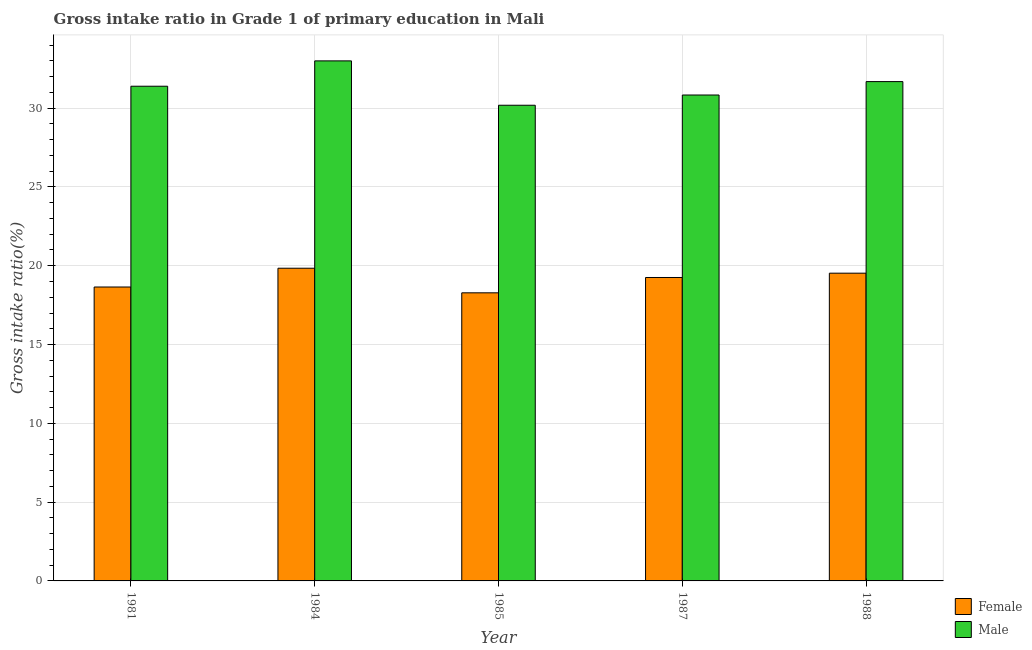How many different coloured bars are there?
Make the answer very short. 2. How many groups of bars are there?
Provide a succinct answer. 5. What is the gross intake ratio(female) in 1988?
Your answer should be compact. 19.53. Across all years, what is the maximum gross intake ratio(male)?
Give a very brief answer. 33. Across all years, what is the minimum gross intake ratio(male)?
Keep it short and to the point. 30.19. In which year was the gross intake ratio(female) maximum?
Offer a very short reply. 1984. In which year was the gross intake ratio(female) minimum?
Ensure brevity in your answer.  1985. What is the total gross intake ratio(male) in the graph?
Offer a terse response. 157.1. What is the difference between the gross intake ratio(female) in 1985 and that in 1987?
Offer a very short reply. -0.97. What is the difference between the gross intake ratio(male) in 1981 and the gross intake ratio(female) in 1987?
Your response must be concise. 0.56. What is the average gross intake ratio(female) per year?
Your answer should be very brief. 19.11. In the year 1987, what is the difference between the gross intake ratio(male) and gross intake ratio(female)?
Your answer should be compact. 0. In how many years, is the gross intake ratio(female) greater than 31 %?
Your answer should be very brief. 0. What is the ratio of the gross intake ratio(female) in 1985 to that in 1987?
Provide a short and direct response. 0.95. What is the difference between the highest and the second highest gross intake ratio(male)?
Offer a very short reply. 1.31. What is the difference between the highest and the lowest gross intake ratio(female)?
Your answer should be compact. 1.56. In how many years, is the gross intake ratio(female) greater than the average gross intake ratio(female) taken over all years?
Give a very brief answer. 3. What does the 1st bar from the right in 1988 represents?
Ensure brevity in your answer.  Male. How many bars are there?
Ensure brevity in your answer.  10. Are all the bars in the graph horizontal?
Your response must be concise. No. What is the difference between two consecutive major ticks on the Y-axis?
Give a very brief answer. 5. Are the values on the major ticks of Y-axis written in scientific E-notation?
Offer a very short reply. No. How many legend labels are there?
Offer a very short reply. 2. What is the title of the graph?
Provide a short and direct response. Gross intake ratio in Grade 1 of primary education in Mali. Does "Quality of trade" appear as one of the legend labels in the graph?
Your answer should be very brief. No. What is the label or title of the Y-axis?
Provide a succinct answer. Gross intake ratio(%). What is the Gross intake ratio(%) in Female in 1981?
Your response must be concise. 18.65. What is the Gross intake ratio(%) of Male in 1981?
Offer a very short reply. 31.39. What is the Gross intake ratio(%) in Female in 1984?
Ensure brevity in your answer.  19.84. What is the Gross intake ratio(%) in Male in 1984?
Your response must be concise. 33. What is the Gross intake ratio(%) in Female in 1985?
Keep it short and to the point. 18.28. What is the Gross intake ratio(%) in Male in 1985?
Keep it short and to the point. 30.19. What is the Gross intake ratio(%) in Female in 1987?
Provide a succinct answer. 19.26. What is the Gross intake ratio(%) of Male in 1987?
Offer a terse response. 30.84. What is the Gross intake ratio(%) of Female in 1988?
Make the answer very short. 19.53. What is the Gross intake ratio(%) of Male in 1988?
Give a very brief answer. 31.69. Across all years, what is the maximum Gross intake ratio(%) of Female?
Offer a very short reply. 19.84. Across all years, what is the maximum Gross intake ratio(%) in Male?
Keep it short and to the point. 33. Across all years, what is the minimum Gross intake ratio(%) in Female?
Provide a short and direct response. 18.28. Across all years, what is the minimum Gross intake ratio(%) in Male?
Make the answer very short. 30.19. What is the total Gross intake ratio(%) in Female in the graph?
Offer a terse response. 95.56. What is the total Gross intake ratio(%) in Male in the graph?
Give a very brief answer. 157.1. What is the difference between the Gross intake ratio(%) of Female in 1981 and that in 1984?
Keep it short and to the point. -1.19. What is the difference between the Gross intake ratio(%) in Male in 1981 and that in 1984?
Your response must be concise. -1.61. What is the difference between the Gross intake ratio(%) in Female in 1981 and that in 1985?
Your answer should be compact. 0.37. What is the difference between the Gross intake ratio(%) of Male in 1981 and that in 1985?
Your response must be concise. 1.21. What is the difference between the Gross intake ratio(%) of Female in 1981 and that in 1987?
Your response must be concise. -0.6. What is the difference between the Gross intake ratio(%) of Male in 1981 and that in 1987?
Offer a very short reply. 0.56. What is the difference between the Gross intake ratio(%) in Female in 1981 and that in 1988?
Provide a succinct answer. -0.88. What is the difference between the Gross intake ratio(%) of Male in 1981 and that in 1988?
Keep it short and to the point. -0.29. What is the difference between the Gross intake ratio(%) of Female in 1984 and that in 1985?
Ensure brevity in your answer.  1.56. What is the difference between the Gross intake ratio(%) of Male in 1984 and that in 1985?
Your answer should be very brief. 2.81. What is the difference between the Gross intake ratio(%) in Female in 1984 and that in 1987?
Your answer should be very brief. 0.59. What is the difference between the Gross intake ratio(%) in Male in 1984 and that in 1987?
Keep it short and to the point. 2.17. What is the difference between the Gross intake ratio(%) in Female in 1984 and that in 1988?
Your answer should be very brief. 0.31. What is the difference between the Gross intake ratio(%) in Male in 1984 and that in 1988?
Your answer should be compact. 1.31. What is the difference between the Gross intake ratio(%) of Female in 1985 and that in 1987?
Offer a terse response. -0.97. What is the difference between the Gross intake ratio(%) in Male in 1985 and that in 1987?
Keep it short and to the point. -0.65. What is the difference between the Gross intake ratio(%) in Female in 1985 and that in 1988?
Your response must be concise. -1.25. What is the difference between the Gross intake ratio(%) in Male in 1985 and that in 1988?
Ensure brevity in your answer.  -1.5. What is the difference between the Gross intake ratio(%) of Female in 1987 and that in 1988?
Offer a very short reply. -0.27. What is the difference between the Gross intake ratio(%) of Male in 1987 and that in 1988?
Your answer should be very brief. -0.85. What is the difference between the Gross intake ratio(%) of Female in 1981 and the Gross intake ratio(%) of Male in 1984?
Your answer should be very brief. -14.35. What is the difference between the Gross intake ratio(%) in Female in 1981 and the Gross intake ratio(%) in Male in 1985?
Provide a short and direct response. -11.53. What is the difference between the Gross intake ratio(%) in Female in 1981 and the Gross intake ratio(%) in Male in 1987?
Give a very brief answer. -12.18. What is the difference between the Gross intake ratio(%) of Female in 1981 and the Gross intake ratio(%) of Male in 1988?
Make the answer very short. -13.03. What is the difference between the Gross intake ratio(%) in Female in 1984 and the Gross intake ratio(%) in Male in 1985?
Offer a terse response. -10.34. What is the difference between the Gross intake ratio(%) of Female in 1984 and the Gross intake ratio(%) of Male in 1987?
Provide a succinct answer. -10.99. What is the difference between the Gross intake ratio(%) in Female in 1984 and the Gross intake ratio(%) in Male in 1988?
Offer a very short reply. -11.84. What is the difference between the Gross intake ratio(%) of Female in 1985 and the Gross intake ratio(%) of Male in 1987?
Give a very brief answer. -12.55. What is the difference between the Gross intake ratio(%) of Female in 1985 and the Gross intake ratio(%) of Male in 1988?
Your response must be concise. -13.4. What is the difference between the Gross intake ratio(%) of Female in 1987 and the Gross intake ratio(%) of Male in 1988?
Make the answer very short. -12.43. What is the average Gross intake ratio(%) in Female per year?
Provide a short and direct response. 19.11. What is the average Gross intake ratio(%) of Male per year?
Your answer should be very brief. 31.42. In the year 1981, what is the difference between the Gross intake ratio(%) in Female and Gross intake ratio(%) in Male?
Your answer should be very brief. -12.74. In the year 1984, what is the difference between the Gross intake ratio(%) of Female and Gross intake ratio(%) of Male?
Provide a short and direct response. -13.16. In the year 1985, what is the difference between the Gross intake ratio(%) in Female and Gross intake ratio(%) in Male?
Your response must be concise. -11.9. In the year 1987, what is the difference between the Gross intake ratio(%) in Female and Gross intake ratio(%) in Male?
Give a very brief answer. -11.58. In the year 1988, what is the difference between the Gross intake ratio(%) of Female and Gross intake ratio(%) of Male?
Provide a succinct answer. -12.16. What is the ratio of the Gross intake ratio(%) of Female in 1981 to that in 1984?
Your answer should be compact. 0.94. What is the ratio of the Gross intake ratio(%) of Male in 1981 to that in 1984?
Offer a very short reply. 0.95. What is the ratio of the Gross intake ratio(%) in Female in 1981 to that in 1985?
Give a very brief answer. 1.02. What is the ratio of the Gross intake ratio(%) in Female in 1981 to that in 1987?
Offer a terse response. 0.97. What is the ratio of the Gross intake ratio(%) in Male in 1981 to that in 1987?
Provide a short and direct response. 1.02. What is the ratio of the Gross intake ratio(%) of Female in 1981 to that in 1988?
Provide a short and direct response. 0.96. What is the ratio of the Gross intake ratio(%) of Male in 1981 to that in 1988?
Your answer should be compact. 0.99. What is the ratio of the Gross intake ratio(%) in Female in 1984 to that in 1985?
Give a very brief answer. 1.09. What is the ratio of the Gross intake ratio(%) of Male in 1984 to that in 1985?
Your response must be concise. 1.09. What is the ratio of the Gross intake ratio(%) in Female in 1984 to that in 1987?
Provide a short and direct response. 1.03. What is the ratio of the Gross intake ratio(%) of Male in 1984 to that in 1987?
Provide a succinct answer. 1.07. What is the ratio of the Gross intake ratio(%) in Female in 1984 to that in 1988?
Keep it short and to the point. 1.02. What is the ratio of the Gross intake ratio(%) in Male in 1984 to that in 1988?
Provide a succinct answer. 1.04. What is the ratio of the Gross intake ratio(%) of Female in 1985 to that in 1987?
Give a very brief answer. 0.95. What is the ratio of the Gross intake ratio(%) of Male in 1985 to that in 1987?
Ensure brevity in your answer.  0.98. What is the ratio of the Gross intake ratio(%) of Female in 1985 to that in 1988?
Provide a short and direct response. 0.94. What is the ratio of the Gross intake ratio(%) in Male in 1985 to that in 1988?
Your answer should be compact. 0.95. What is the ratio of the Gross intake ratio(%) in Male in 1987 to that in 1988?
Provide a short and direct response. 0.97. What is the difference between the highest and the second highest Gross intake ratio(%) of Female?
Keep it short and to the point. 0.31. What is the difference between the highest and the second highest Gross intake ratio(%) of Male?
Provide a short and direct response. 1.31. What is the difference between the highest and the lowest Gross intake ratio(%) in Female?
Give a very brief answer. 1.56. What is the difference between the highest and the lowest Gross intake ratio(%) of Male?
Provide a succinct answer. 2.81. 